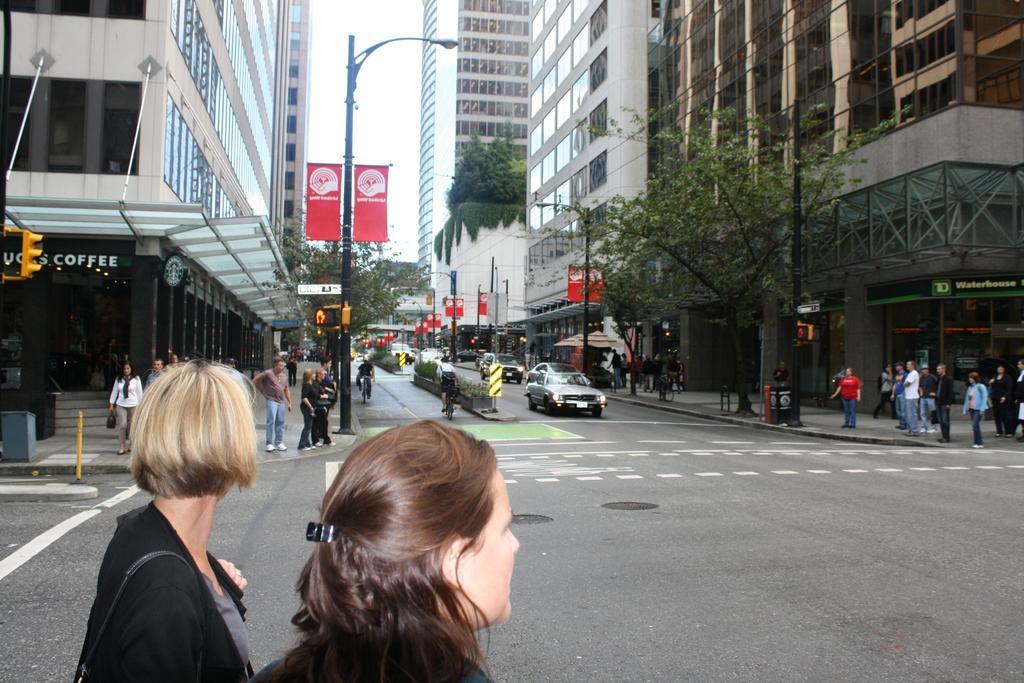Could you give a brief overview of what you see in this image? In this image, we can see so many buildings, glass, walls, pillars, poles with lights, banners, sign boards, traffic signals, trees. Here we can see a group of people. Few are standing and walking. In the middle we can see a roads with lines. Few vehicles are on the road. Background there is a sky. 